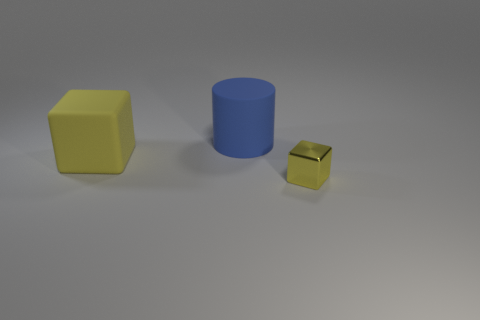Is there another yellow object that has the same shape as the large yellow rubber thing?
Ensure brevity in your answer.  Yes. The rubber thing that is on the right side of the cube behind the yellow metal object is what shape?
Keep it short and to the point. Cylinder. What color is the big rubber object that is on the right side of the big yellow object?
Your answer should be very brief. Blue. The yellow object that is made of the same material as the blue cylinder is what size?
Give a very brief answer. Large. What is the size of the other yellow object that is the same shape as the small yellow metal thing?
Your answer should be compact. Large. Are any blue metallic spheres visible?
Ensure brevity in your answer.  No. What number of things are either blocks behind the metal block or matte cubes?
Give a very brief answer. 1. What is the material of the cylinder that is the same size as the yellow rubber cube?
Provide a succinct answer. Rubber. The thing that is behind the cube behind the small yellow object is what color?
Your answer should be compact. Blue. There is a blue rubber thing; how many big yellow rubber blocks are behind it?
Provide a succinct answer. 0. 